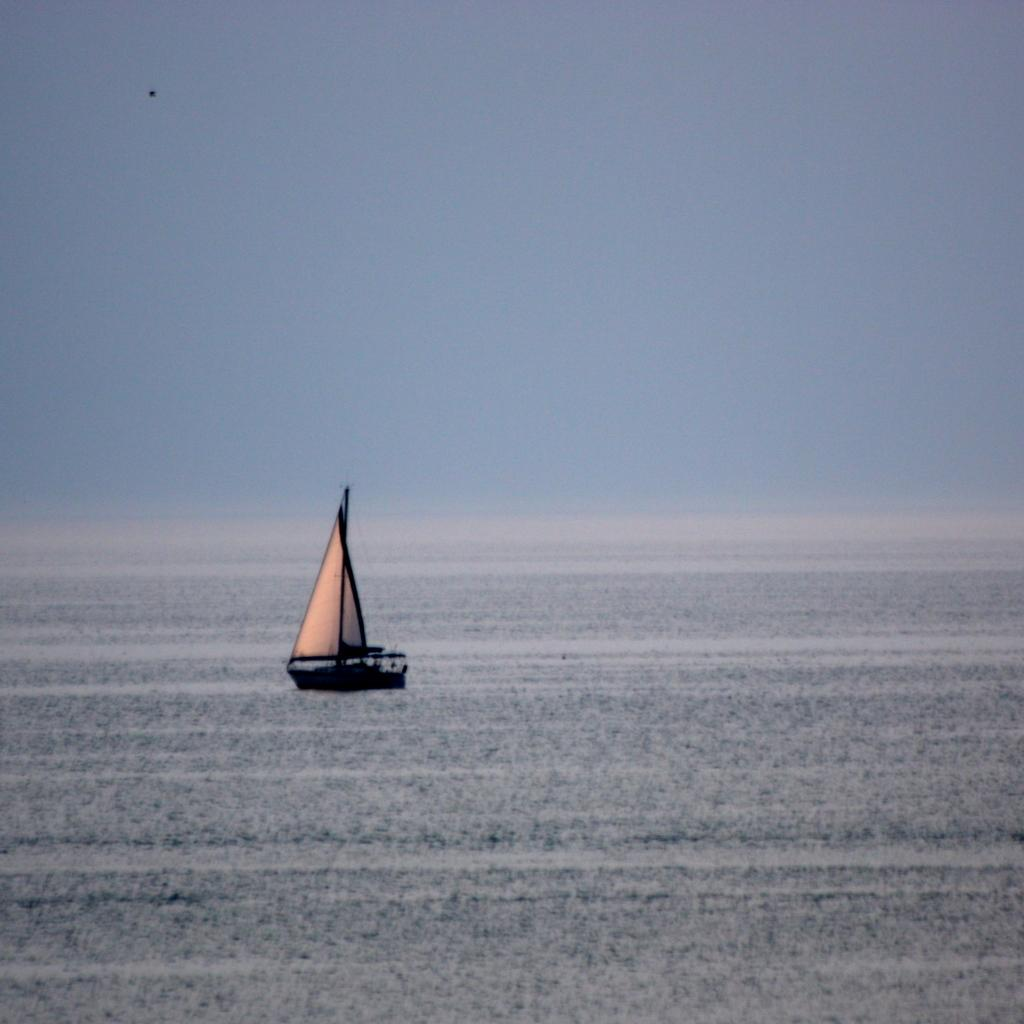What is the main subject in the middle of the image? There is a ship in the middle of the image. What can be seen in the background of the image? The sky is visible in the background of the image. What is the color of the sky in the image? The color of the sky appears to be blue. Where is the library located in the image? There is no library present in the image; it features a ship and a blue sky. How many ducks are swimming in the water near the ship? There are no ducks visible in the image; it only shows a ship and a blue sky. 